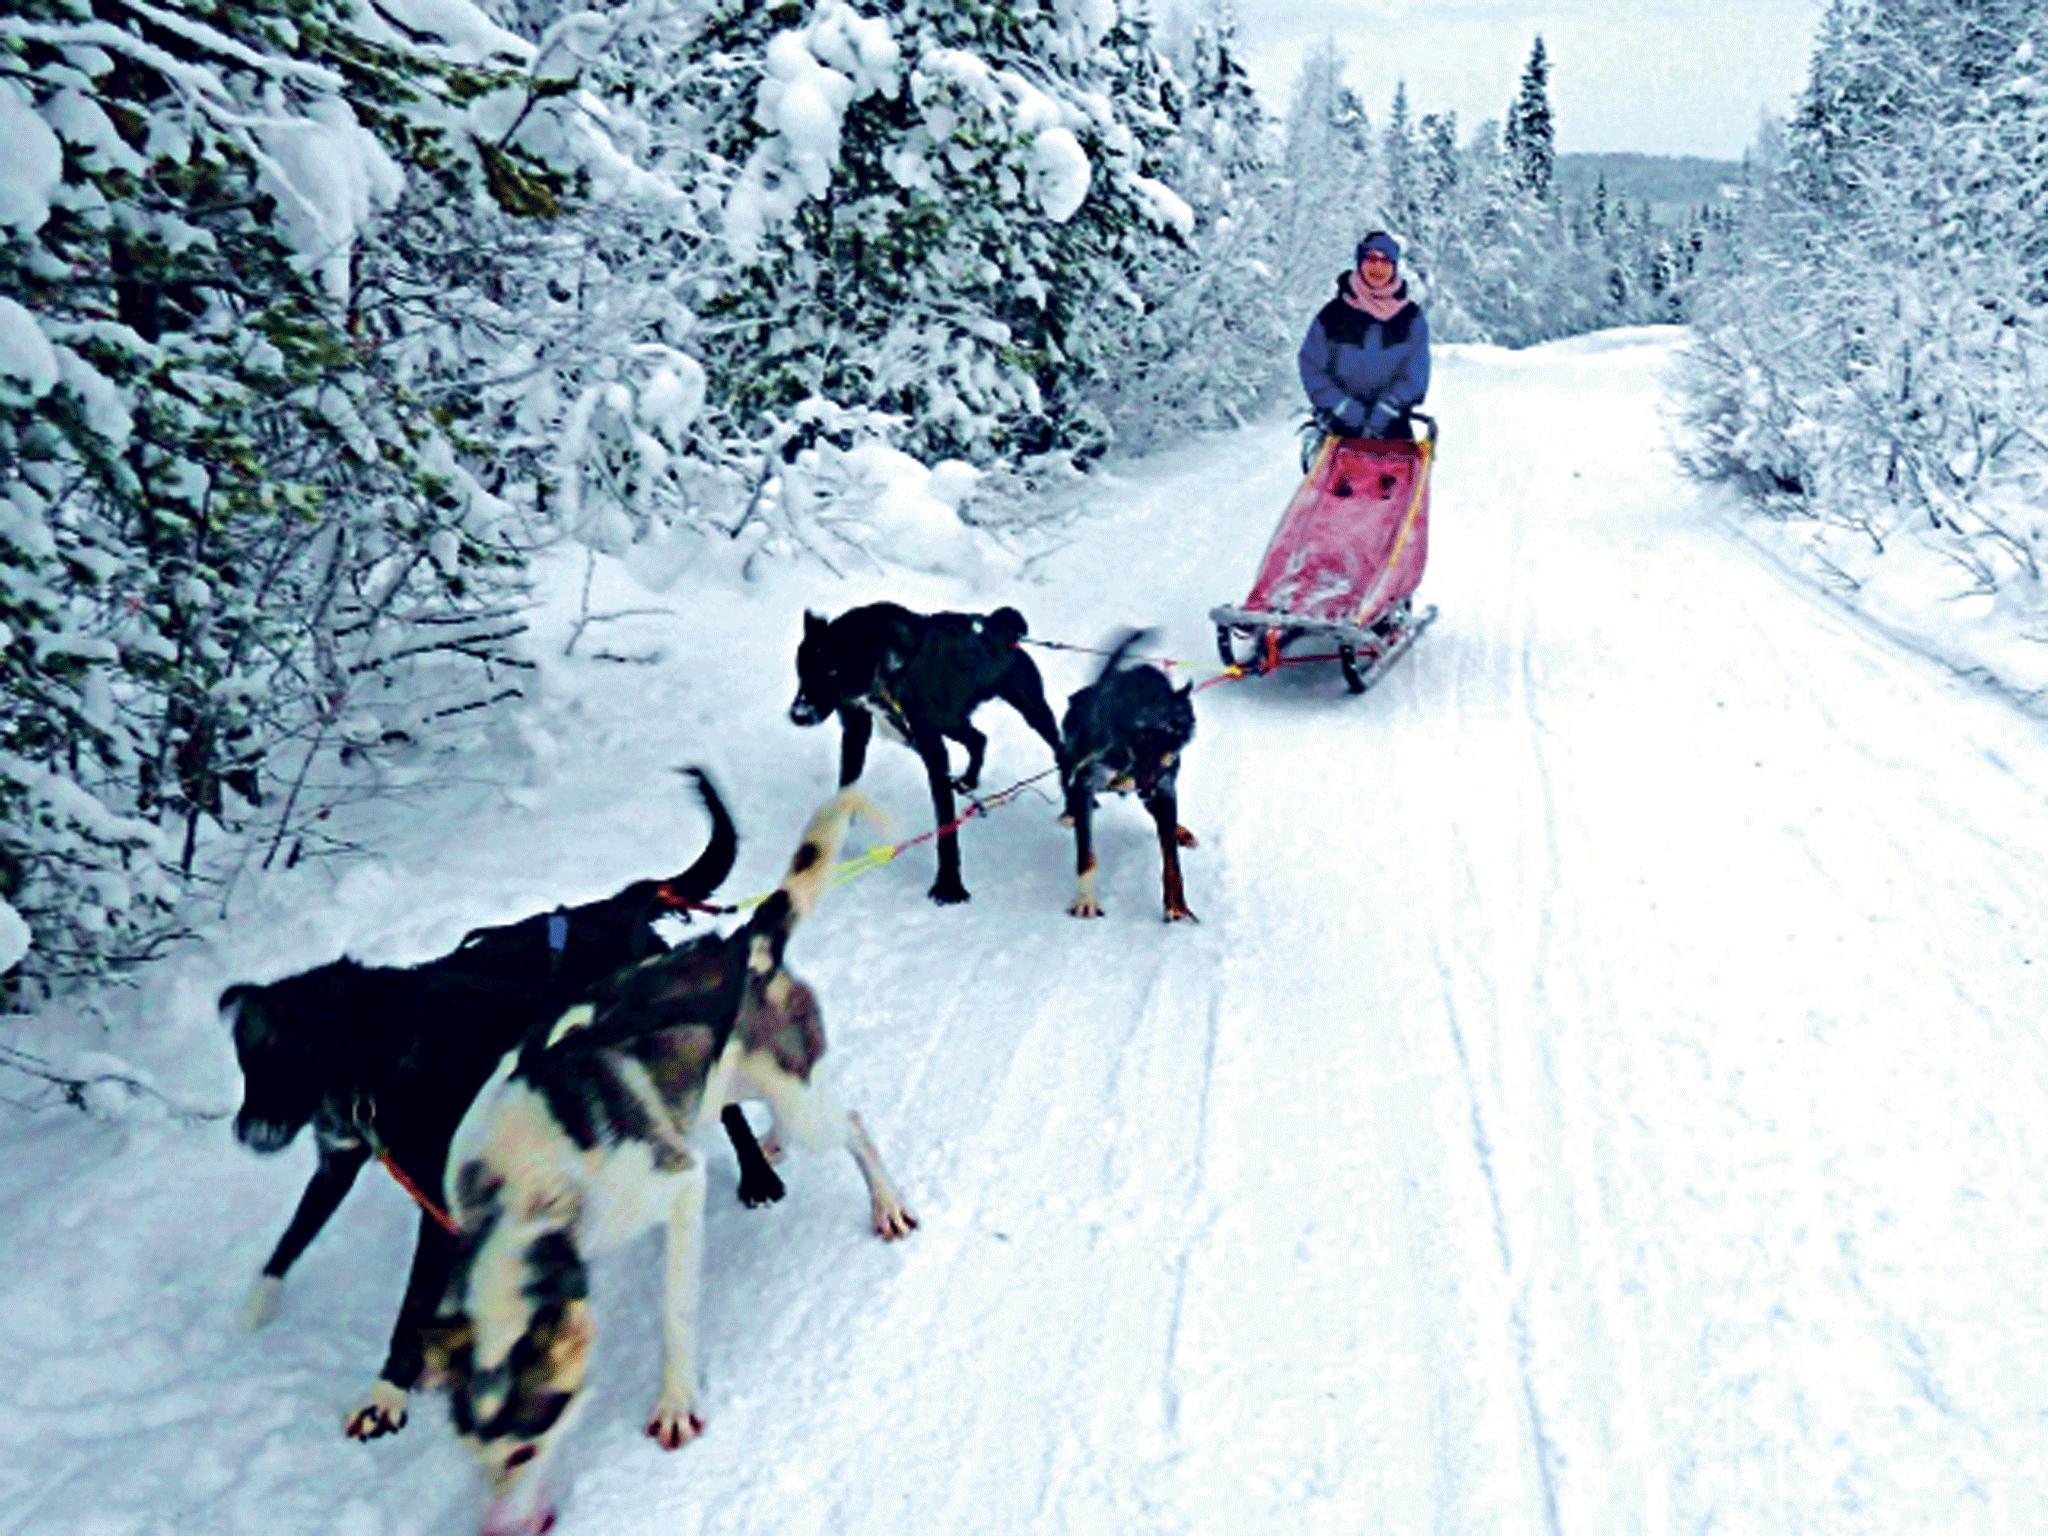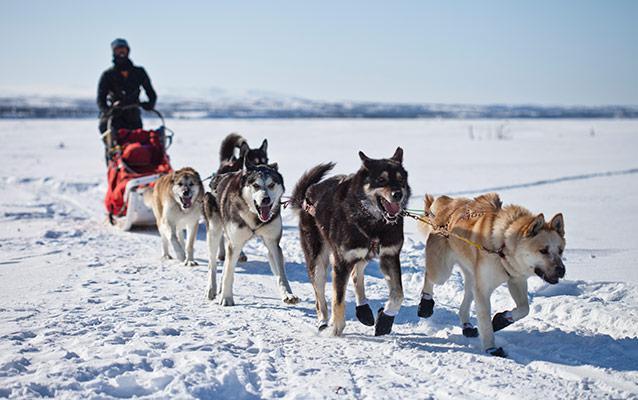The first image is the image on the left, the second image is the image on the right. Evaluate the accuracy of this statement regarding the images: "At least one lead dog clearly has their tongue hanging out.". Is it true? Answer yes or no. No. The first image is the image on the left, the second image is the image on the right. Evaluate the accuracy of this statement regarding the images: "A team of dogs is heading down a path lined with snow-covered trees.". Is it true? Answer yes or no. Yes. 